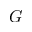Convert formula to latex. <formula><loc_0><loc_0><loc_500><loc_500>G</formula> 